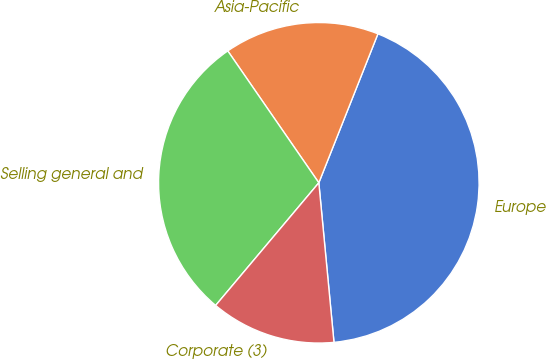Convert chart. <chart><loc_0><loc_0><loc_500><loc_500><pie_chart><fcel>Europe<fcel>Asia-Pacific<fcel>Selling general and<fcel>Corporate (3)<nl><fcel>42.48%<fcel>15.63%<fcel>29.25%<fcel>12.64%<nl></chart> 